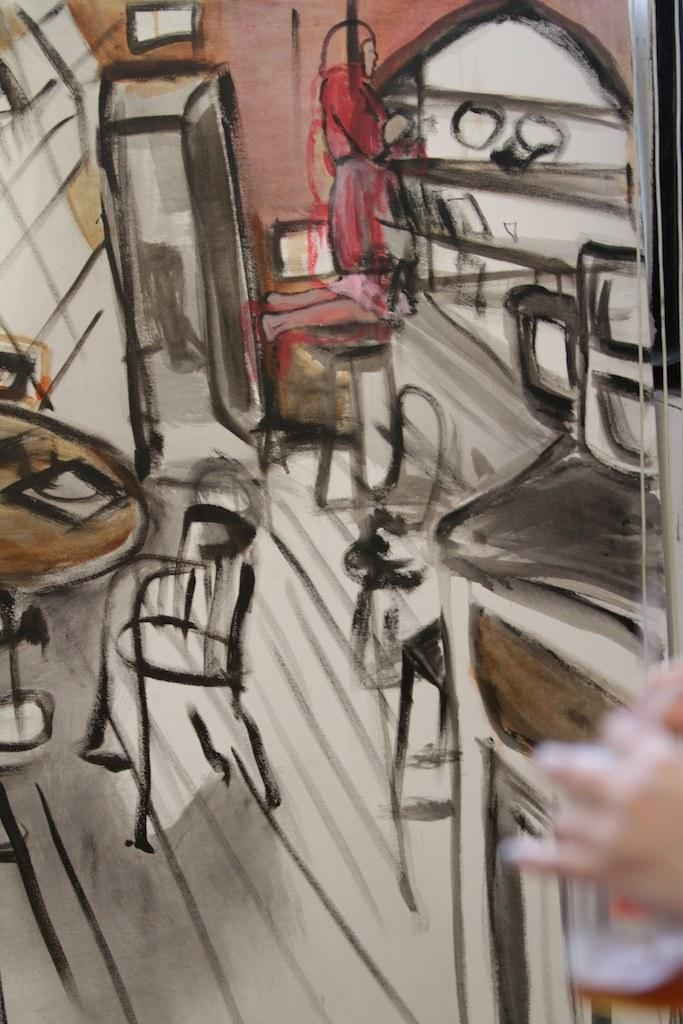What is depicted in the image? There is a drawing of a person in the image. What type of furniture is present in the image? There are chairs and a table in the image. Can you describe any other objects in the image? There are unspecified objects in the image. What is the cause of the gold color in the image? There is no gold color present in the image. Can you tell me who is writing the text in the image? There is no writing or text present in the image. 